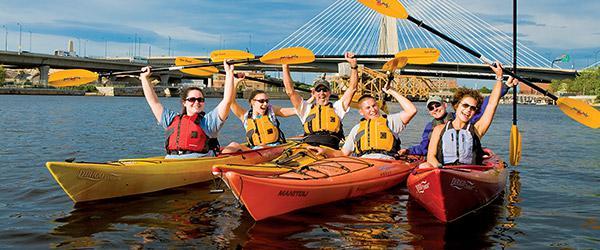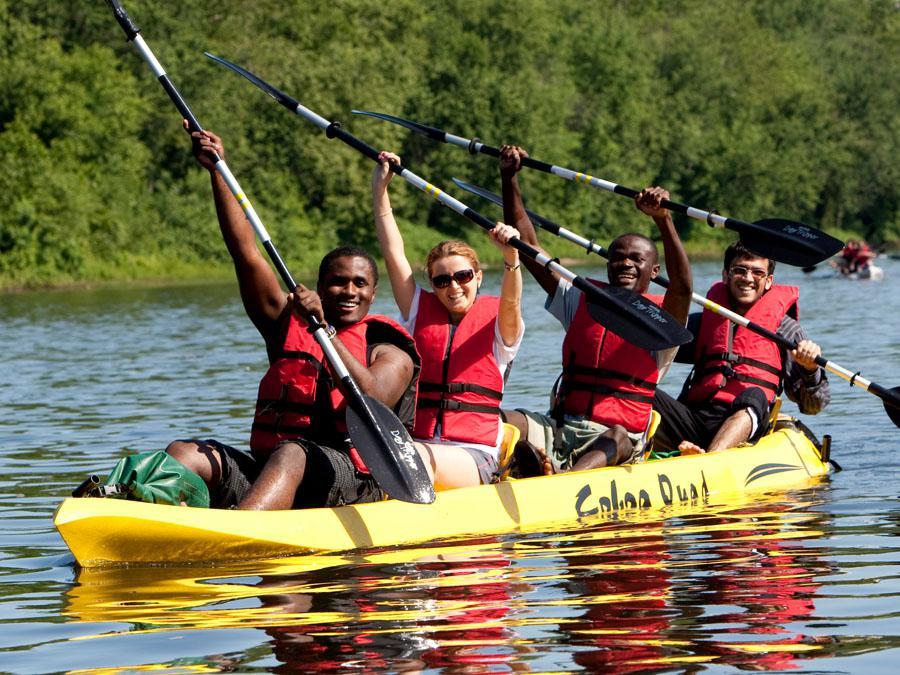The first image is the image on the left, the second image is the image on the right. Analyze the images presented: Is the assertion "The left image includes a canoe in the foreground heading away from the camera, and the right image shows at least one forward moving kayak-type boat." valid? Answer yes or no. No. The first image is the image on the left, the second image is the image on the right. Assess this claim about the two images: "In the image on the right, four people are riding in one canoe.". Correct or not? Answer yes or no. Yes. 